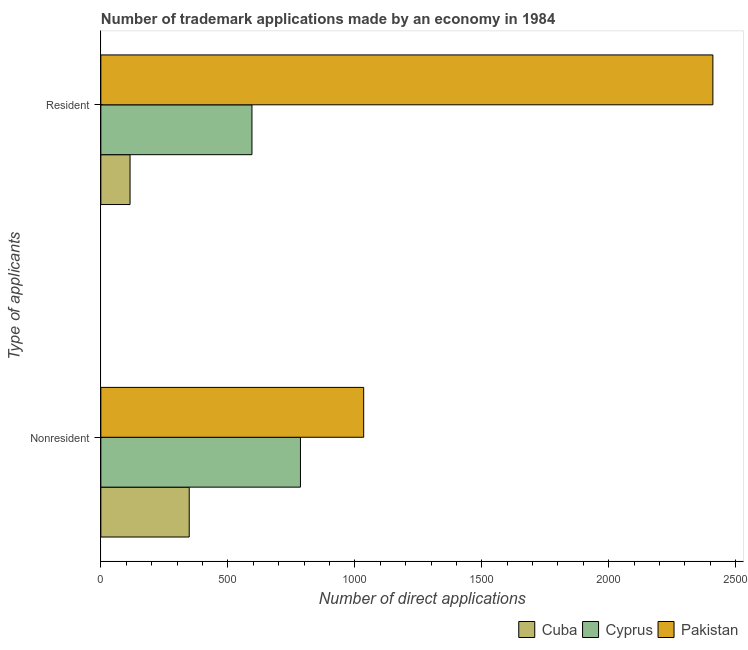How many different coloured bars are there?
Provide a short and direct response. 3. How many groups of bars are there?
Make the answer very short. 2. Are the number of bars on each tick of the Y-axis equal?
Provide a short and direct response. Yes. How many bars are there on the 2nd tick from the bottom?
Provide a succinct answer. 3. What is the label of the 2nd group of bars from the top?
Your response must be concise. Nonresident. What is the number of trademark applications made by residents in Cyprus?
Offer a terse response. 595. Across all countries, what is the maximum number of trademark applications made by non residents?
Make the answer very short. 1035. Across all countries, what is the minimum number of trademark applications made by residents?
Your answer should be compact. 115. In which country was the number of trademark applications made by non residents maximum?
Offer a very short reply. Pakistan. In which country was the number of trademark applications made by non residents minimum?
Keep it short and to the point. Cuba. What is the total number of trademark applications made by non residents in the graph?
Make the answer very short. 2169. What is the difference between the number of trademark applications made by non residents in Pakistan and that in Cuba?
Your answer should be very brief. 687. What is the difference between the number of trademark applications made by residents in Cyprus and the number of trademark applications made by non residents in Cuba?
Keep it short and to the point. 247. What is the average number of trademark applications made by residents per country?
Ensure brevity in your answer.  1040. What is the difference between the number of trademark applications made by residents and number of trademark applications made by non residents in Cyprus?
Provide a succinct answer. -191. What is the ratio of the number of trademark applications made by non residents in Pakistan to that in Cyprus?
Offer a terse response. 1.32. What does the 2nd bar from the bottom in Nonresident represents?
Provide a succinct answer. Cyprus. How many bars are there?
Your answer should be compact. 6. Are all the bars in the graph horizontal?
Ensure brevity in your answer.  Yes. Are the values on the major ticks of X-axis written in scientific E-notation?
Provide a short and direct response. No. Does the graph contain any zero values?
Give a very brief answer. No. How many legend labels are there?
Provide a short and direct response. 3. How are the legend labels stacked?
Make the answer very short. Horizontal. What is the title of the graph?
Provide a short and direct response. Number of trademark applications made by an economy in 1984. What is the label or title of the X-axis?
Make the answer very short. Number of direct applications. What is the label or title of the Y-axis?
Ensure brevity in your answer.  Type of applicants. What is the Number of direct applications in Cuba in Nonresident?
Your answer should be compact. 348. What is the Number of direct applications in Cyprus in Nonresident?
Offer a terse response. 786. What is the Number of direct applications of Pakistan in Nonresident?
Ensure brevity in your answer.  1035. What is the Number of direct applications of Cuba in Resident?
Ensure brevity in your answer.  115. What is the Number of direct applications in Cyprus in Resident?
Ensure brevity in your answer.  595. What is the Number of direct applications in Pakistan in Resident?
Your answer should be very brief. 2410. Across all Type of applicants, what is the maximum Number of direct applications in Cuba?
Offer a terse response. 348. Across all Type of applicants, what is the maximum Number of direct applications of Cyprus?
Provide a short and direct response. 786. Across all Type of applicants, what is the maximum Number of direct applications of Pakistan?
Provide a short and direct response. 2410. Across all Type of applicants, what is the minimum Number of direct applications in Cuba?
Provide a short and direct response. 115. Across all Type of applicants, what is the minimum Number of direct applications of Cyprus?
Your answer should be compact. 595. Across all Type of applicants, what is the minimum Number of direct applications of Pakistan?
Offer a very short reply. 1035. What is the total Number of direct applications of Cuba in the graph?
Provide a short and direct response. 463. What is the total Number of direct applications in Cyprus in the graph?
Your response must be concise. 1381. What is the total Number of direct applications in Pakistan in the graph?
Make the answer very short. 3445. What is the difference between the Number of direct applications of Cuba in Nonresident and that in Resident?
Offer a very short reply. 233. What is the difference between the Number of direct applications in Cyprus in Nonresident and that in Resident?
Provide a short and direct response. 191. What is the difference between the Number of direct applications in Pakistan in Nonresident and that in Resident?
Your answer should be compact. -1375. What is the difference between the Number of direct applications of Cuba in Nonresident and the Number of direct applications of Cyprus in Resident?
Your answer should be compact. -247. What is the difference between the Number of direct applications in Cuba in Nonresident and the Number of direct applications in Pakistan in Resident?
Provide a succinct answer. -2062. What is the difference between the Number of direct applications in Cyprus in Nonresident and the Number of direct applications in Pakistan in Resident?
Provide a succinct answer. -1624. What is the average Number of direct applications of Cuba per Type of applicants?
Offer a terse response. 231.5. What is the average Number of direct applications of Cyprus per Type of applicants?
Offer a very short reply. 690.5. What is the average Number of direct applications of Pakistan per Type of applicants?
Offer a very short reply. 1722.5. What is the difference between the Number of direct applications of Cuba and Number of direct applications of Cyprus in Nonresident?
Give a very brief answer. -438. What is the difference between the Number of direct applications in Cuba and Number of direct applications in Pakistan in Nonresident?
Give a very brief answer. -687. What is the difference between the Number of direct applications of Cyprus and Number of direct applications of Pakistan in Nonresident?
Keep it short and to the point. -249. What is the difference between the Number of direct applications in Cuba and Number of direct applications in Cyprus in Resident?
Your response must be concise. -480. What is the difference between the Number of direct applications of Cuba and Number of direct applications of Pakistan in Resident?
Offer a very short reply. -2295. What is the difference between the Number of direct applications in Cyprus and Number of direct applications in Pakistan in Resident?
Ensure brevity in your answer.  -1815. What is the ratio of the Number of direct applications in Cuba in Nonresident to that in Resident?
Offer a very short reply. 3.03. What is the ratio of the Number of direct applications in Cyprus in Nonresident to that in Resident?
Keep it short and to the point. 1.32. What is the ratio of the Number of direct applications in Pakistan in Nonresident to that in Resident?
Offer a very short reply. 0.43. What is the difference between the highest and the second highest Number of direct applications in Cuba?
Your response must be concise. 233. What is the difference between the highest and the second highest Number of direct applications of Cyprus?
Keep it short and to the point. 191. What is the difference between the highest and the second highest Number of direct applications in Pakistan?
Make the answer very short. 1375. What is the difference between the highest and the lowest Number of direct applications of Cuba?
Make the answer very short. 233. What is the difference between the highest and the lowest Number of direct applications of Cyprus?
Make the answer very short. 191. What is the difference between the highest and the lowest Number of direct applications of Pakistan?
Offer a terse response. 1375. 